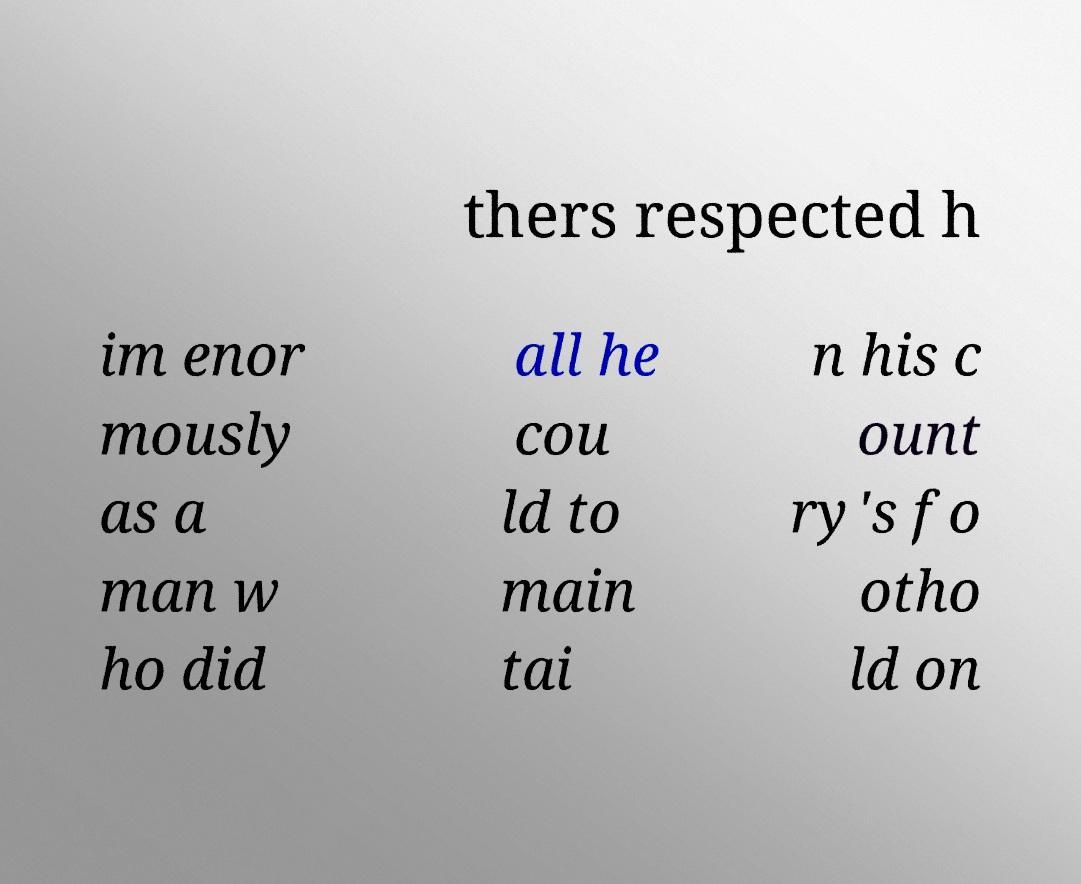Can you accurately transcribe the text from the provided image for me? thers respected h im enor mously as a man w ho did all he cou ld to main tai n his c ount ry's fo otho ld on 